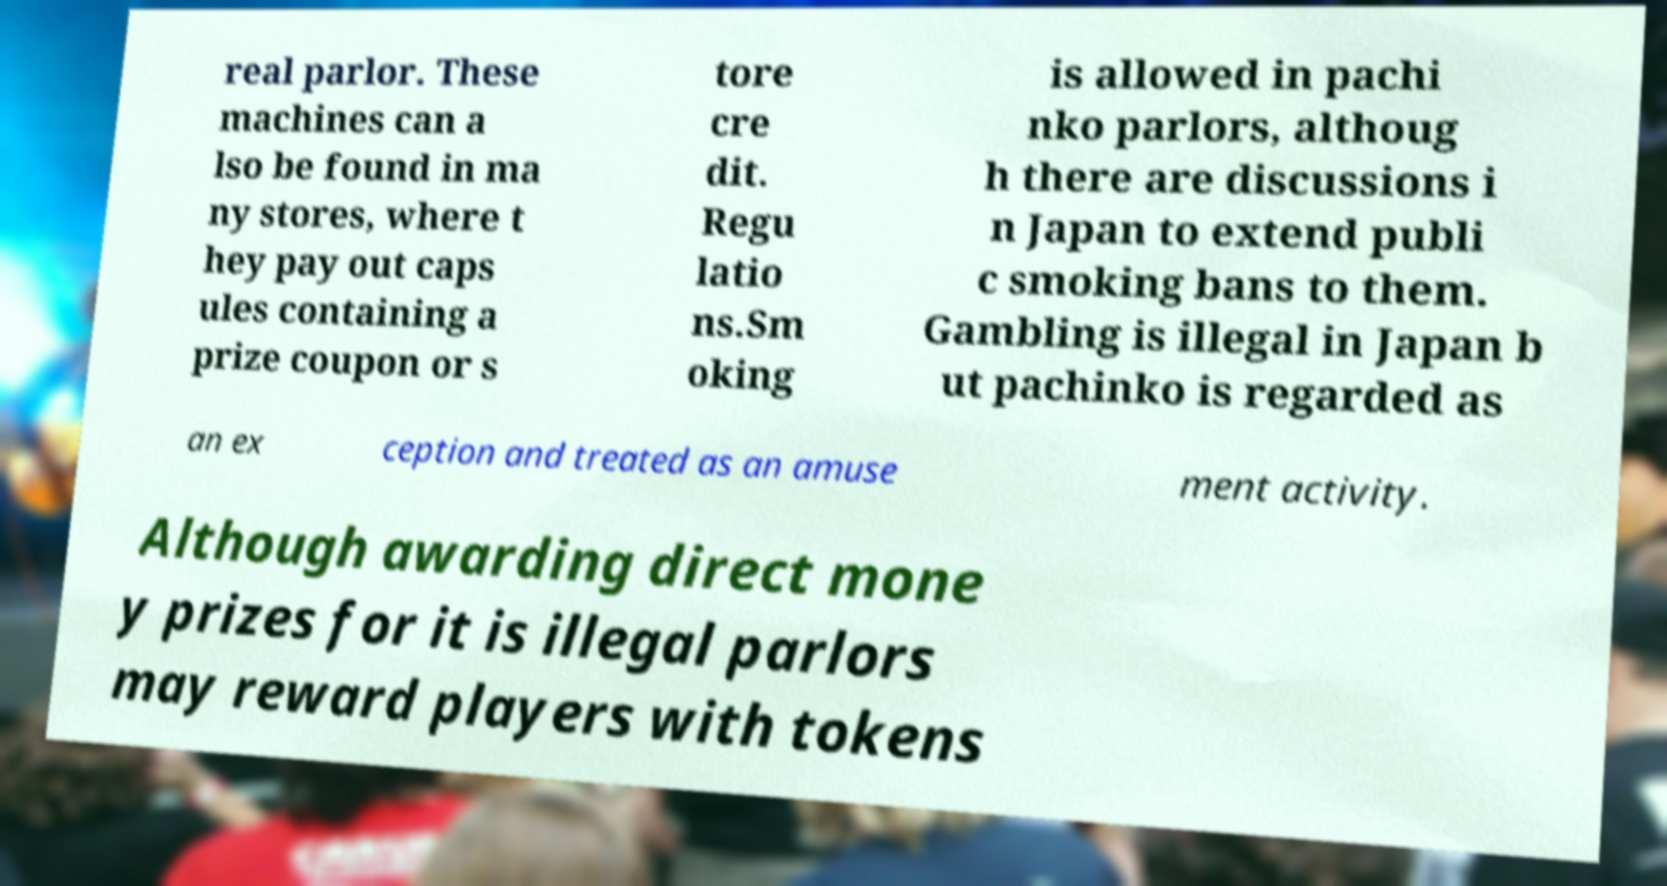Can you read and provide the text displayed in the image?This photo seems to have some interesting text. Can you extract and type it out for me? real parlor. These machines can a lso be found in ma ny stores, where t hey pay out caps ules containing a prize coupon or s tore cre dit. Regu latio ns.Sm oking is allowed in pachi nko parlors, althoug h there are discussions i n Japan to extend publi c smoking bans to them. Gambling is illegal in Japan b ut pachinko is regarded as an ex ception and treated as an amuse ment activity. Although awarding direct mone y prizes for it is illegal parlors may reward players with tokens 